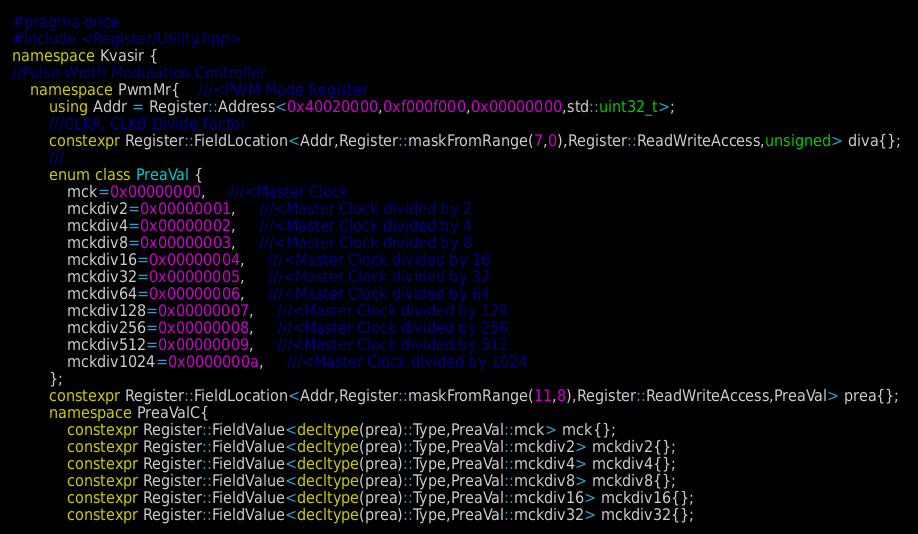<code> <loc_0><loc_0><loc_500><loc_500><_C++_>#pragma once 
#include <Register/Utility.hpp>
namespace Kvasir {
//Pulse Width Modulation Controller
    namespace PwmMr{    ///<PWM Mode Register
        using Addr = Register::Address<0x40020000,0xf000f000,0x00000000,std::uint32_t>;
        ///CLKA, CLKB Divide Factor
        constexpr Register::FieldLocation<Addr,Register::maskFromRange(7,0),Register::ReadWriteAccess,unsigned> diva{}; 
        ///
        enum class PreaVal {
            mck=0x00000000,     ///<Master Clock
            mckdiv2=0x00000001,     ///<Master Clock divided by 2
            mckdiv4=0x00000002,     ///<Master Clock divided by 4
            mckdiv8=0x00000003,     ///<Master Clock divided by 8
            mckdiv16=0x00000004,     ///<Master Clock divided by 16
            mckdiv32=0x00000005,     ///<Master Clock divided by 32
            mckdiv64=0x00000006,     ///<Master Clock divided by 64
            mckdiv128=0x00000007,     ///<Master Clock divided by 128
            mckdiv256=0x00000008,     ///<Master Clock divided by 256
            mckdiv512=0x00000009,     ///<Master Clock divided by 512
            mckdiv1024=0x0000000a,     ///<Master Clock divided by 1024
        };
        constexpr Register::FieldLocation<Addr,Register::maskFromRange(11,8),Register::ReadWriteAccess,PreaVal> prea{}; 
        namespace PreaValC{
            constexpr Register::FieldValue<decltype(prea)::Type,PreaVal::mck> mck{};
            constexpr Register::FieldValue<decltype(prea)::Type,PreaVal::mckdiv2> mckdiv2{};
            constexpr Register::FieldValue<decltype(prea)::Type,PreaVal::mckdiv4> mckdiv4{};
            constexpr Register::FieldValue<decltype(prea)::Type,PreaVal::mckdiv8> mckdiv8{};
            constexpr Register::FieldValue<decltype(prea)::Type,PreaVal::mckdiv16> mckdiv16{};
            constexpr Register::FieldValue<decltype(prea)::Type,PreaVal::mckdiv32> mckdiv32{};</code> 